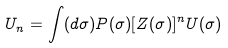<formula> <loc_0><loc_0><loc_500><loc_500>U _ { n } = \int ( d \sigma ) P ( \sigma ) [ Z ( \sigma ) ] ^ { n } U ( \sigma )</formula> 